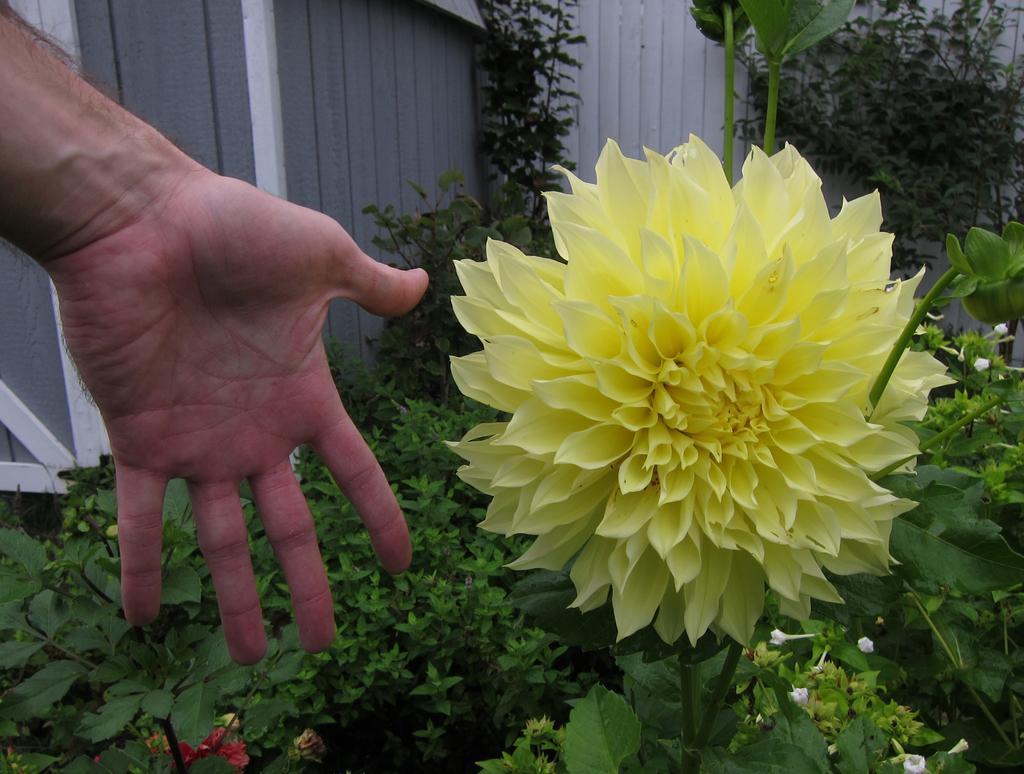Please provide a concise description of this image. On the left side of the image we can see a person hand. On the right side of the image we can see a yellow color flower and some white color flowers. In the background of the image we can see plants. 